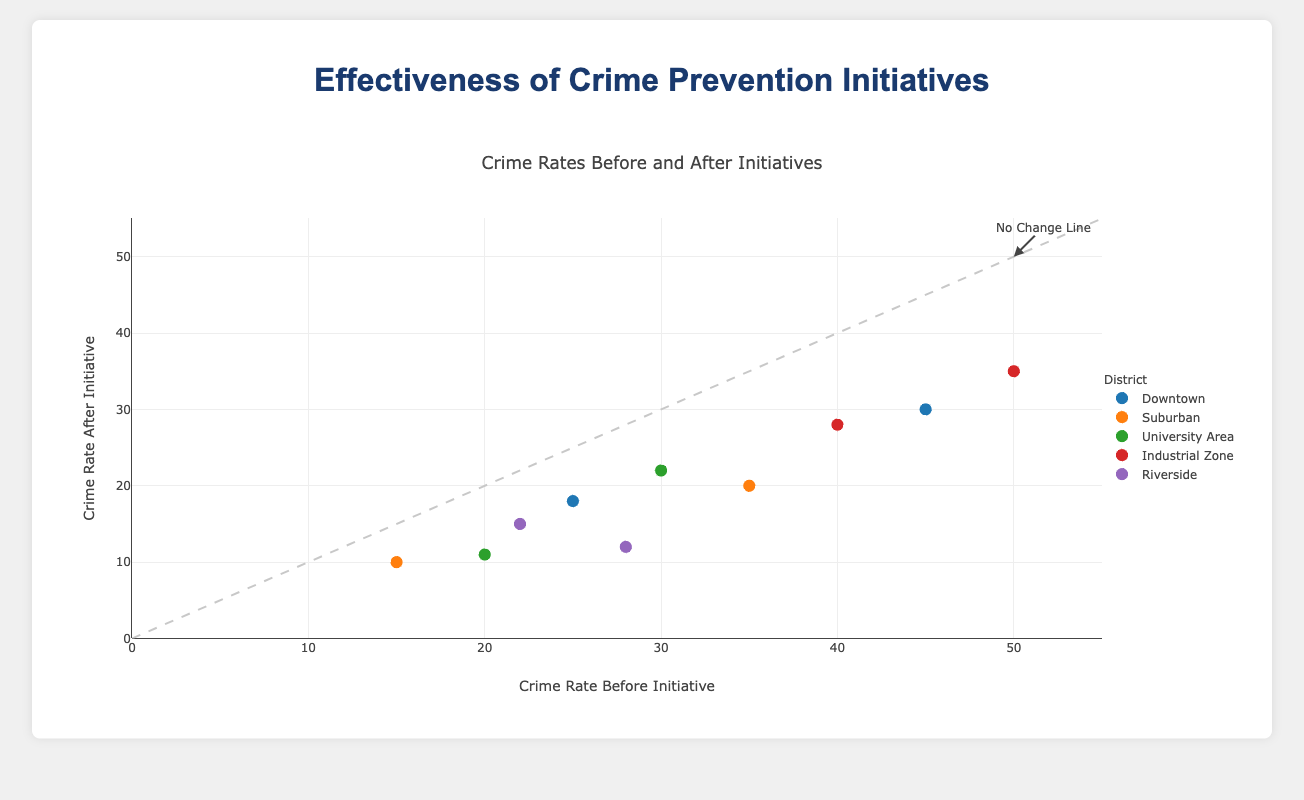What is the title of the plot? The title is usually displayed at the top of the plot and provides a brief description of what the plot represents. The title of the plot is "Crime Rates Before and After Initiatives" as indicated in the script.
Answer: Crime Rates Before and After Initiatives What are the axes titles of the plot? The axes titles are located beside each axis. According to the script, the x-axis title is "Crime Rate Before Initiative" and the y-axis title is "Crime Rate After Initiative".
Answer: Crime Rate Before Initiative (x-axis), Crime Rate After Initiative (y-axis) How many districts are shown in the plot? Each district is represented in the legend. According to the `districts` array derived from the data, there are five districts: Downtown, Suburban, University Area, Industrial Zone, and Riverside.
Answer: 5 Which district shows the highest reduction in burglaries? Identify the points associated with burglaries in each district and compare the reductions. The Industrial Zone shows the highest reduction with burglaries going from 50 to 35, a reduction of 15 crimes.
Answer: Industrial Zone What crime prevention initiative was used most frequently across all districts for burglaries and assaults? Analyze the `Initiative` attribute for all data points. "Increased Patrol" and "CCTV Installation" were used twice each, but "Neighborhood Watch" was used in two different districts, hence more frequently.
Answer: Neighborhood Watch Which district shows the smallest reduction in assaults? Identify the points associated with assaults in each district and compare the reductions. The Suburban district shows the smallest reduction with assaults going from 15 to 10, a reduction of 5 crimes.
Answer: Suburban What is the color associated with the Riverside district in the plot? Riverside is one of the districts listed in the `districts` array, and the color assigned to it is the fifth color in the `colors` array. It is purple based on the color names mentioned.
Answer: Purple Is there any data point showing no reduction in crime after the initiative? Compare the 'Before' and 'After' values for all data points. All data points show some reduction (the 'After' rate is always lower than 'Before').
Answer: No Which district shows a reduction in both burglaries and assaults due to "CCTV Installation"? Look for "CCTV Installation" in the `Initiative` field, specifically within each district. Downtown and University Area each show reduction in assaults due to "CCTV Installation", but only Downtown shows specific initiatives corresponding to both burglary and assault reductions.
Answer: Downtown If you sum the reductions in burglaries for all districts, what is the value? Sum the differences between 'Before' and 'After' for burglaries across all districts: (45-30) + (35-20) + (20-11) + (50-35) + (28-12) = 15 + 15 + 9 + 15 + 16 = 70.
Answer: 70 